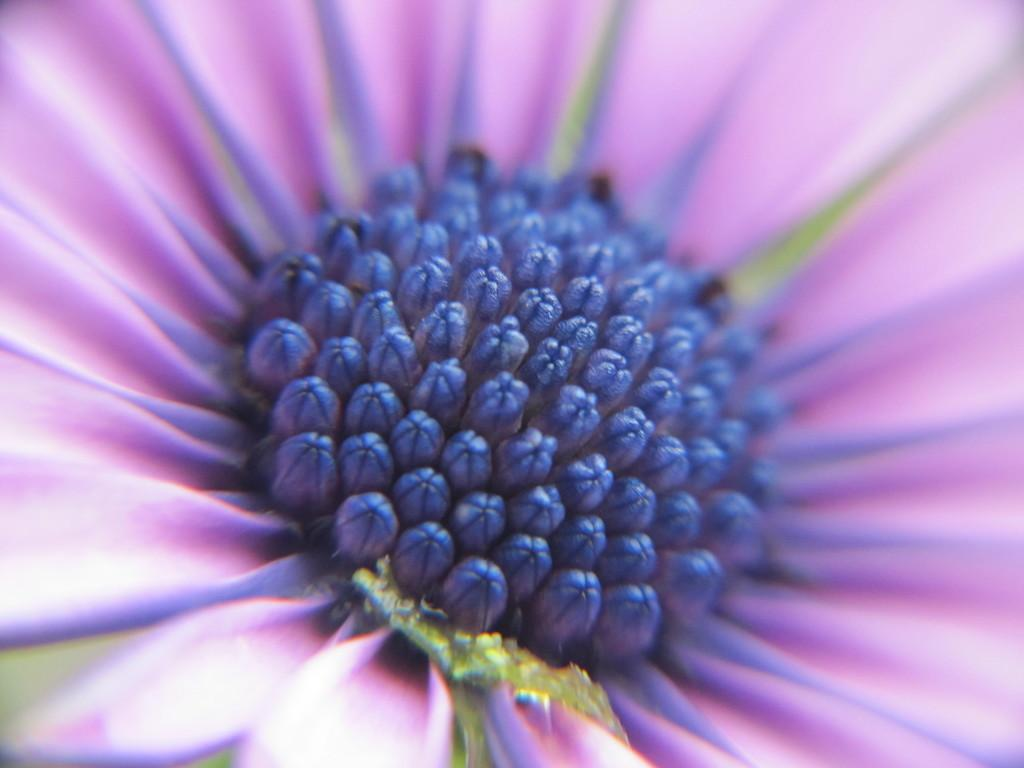What type of flower is present in the image? There is a violet color flower in the image. Can you see a mountain in the background of the image? There is no mention of a mountain in the provided facts, and therefore it cannot be determined if a mountain is present in the image. 